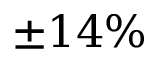Convert formula to latex. <formula><loc_0><loc_0><loc_500><loc_500>\pm 1 4 \%</formula> 